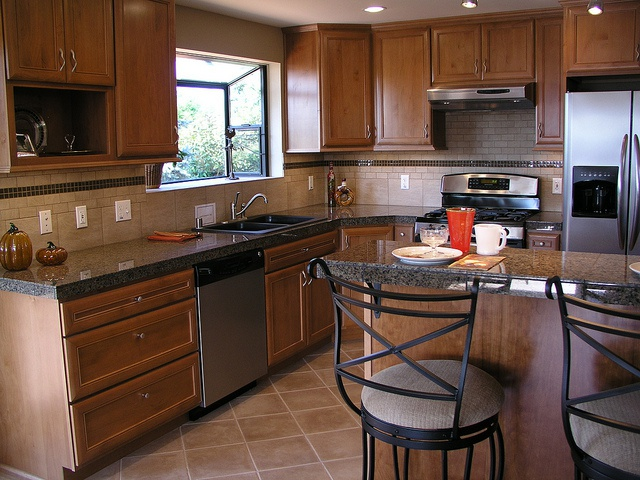Describe the objects in this image and their specific colors. I can see chair in black, gray, and brown tones, refrigerator in black, lavender, gray, and darkgray tones, chair in black, gray, and maroon tones, oven in black, gray, darkgray, and lightgray tones, and sink in black and gray tones in this image. 